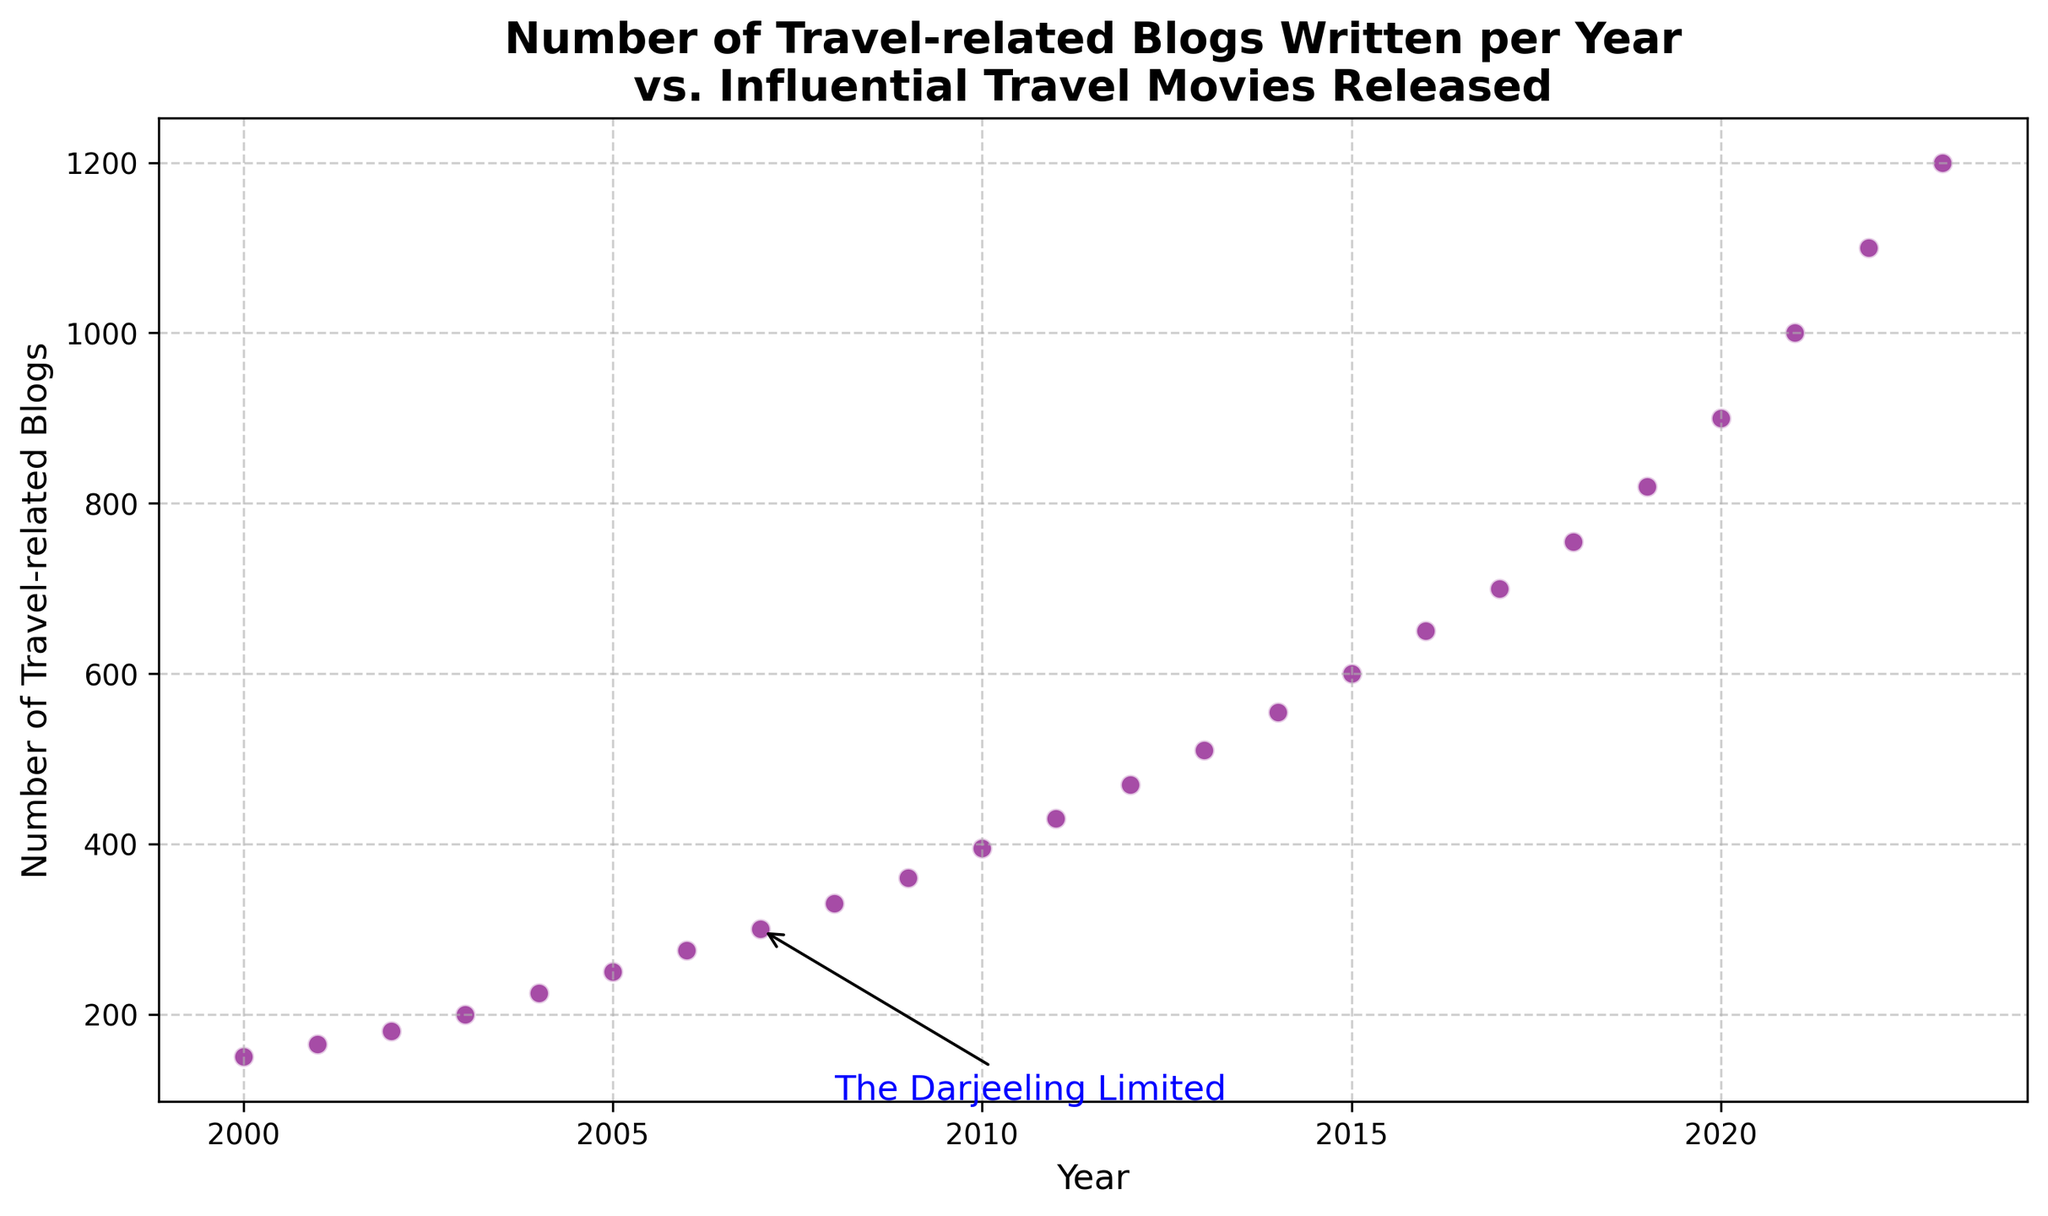What year was "The Darjeeling Limited" released, and how many travel-related blogs were written that year? Find "The Darjeeling Limited" on the scatter plot, which is annotated. The corresponding year is 2007, and the number of blogs written that year is 300.
Answer: 2007, 300 How does the number of blogs written in 2010 compare to the number written in 2007? Locate the data points for 2010 and 2007. In 2010, 395 blogs were written, and in 2007, 300 blogs were written. Thus, 95 more blogs were written in 2010 compared to 2007.
Answer: 95 more What is the trend of the number of travel-related blogs over the years? Examine the scatter plot for the general direction of the data points. The number of travel-related blogs increases consistently each year.
Answer: Increasing Among the movies listed, which one was released in a year with the highest number of travel-related blogs, and how many blogs were written that year? Find the movie in the plot where the number of travel-related blogs is highest. In 2023, 1200 blogs were written, and the movie "Beast" was released.
Answer: Beast, 1200 In which year did the number of travel-related blogs first exceed 500, and what influential travel movie was released that year? Locate the point where the number of blogs exceeds 500 for the first time. It's at 2013 with 510 blogs. No influential movie was released that year.
Answer: 2013, None What is the median number of travel-related blogs written from 2000 to 2023? List the blog numbers: 150, 165, 180, 200, 225, 250, 275, 300, 330, 360, 395, 430, 470, 510, 555, 600, 650, 700, 755, 820, 900, 1000, 1100, 1200. There are 24 numbers; the median is the average of the 12th and 13th entries (395 and 430). Calculate (395+430)/2.
Answer: 412.5 In which years was there a noticeable jump in the number of travel-related blogs from the previous year? Compare the number of blogs year over year and identify significant increases. Notable jumps occurred from 2004 to 2005 (25 blogs), 2007 to 2008 (30 blogs), 2010 to 2011 (35 blogs), and 2020 to 2021 (100 blogs).
Answer: 2004-2005, 2007-2008, 2010-2011, 2020-2021 Which movie release in the plotted years corresponds to the maximum number of travel-related blogs written, and how many were there? Locate the highest number of blogs and see if an influential travel movie is listed for that year. In 2023, 1200 blogs were written, and the movie was "Beast."
Answer: Beast, 1200 What was the difference in the number of travel-related blogs between the years when "The Darjeeling Limited" and "Eat Pray Love" were released? Find the data points for 2007 (300 blogs) and 2010 (395 blogs). Subtract 300 from 395 to find the difference.
Answer: 95 